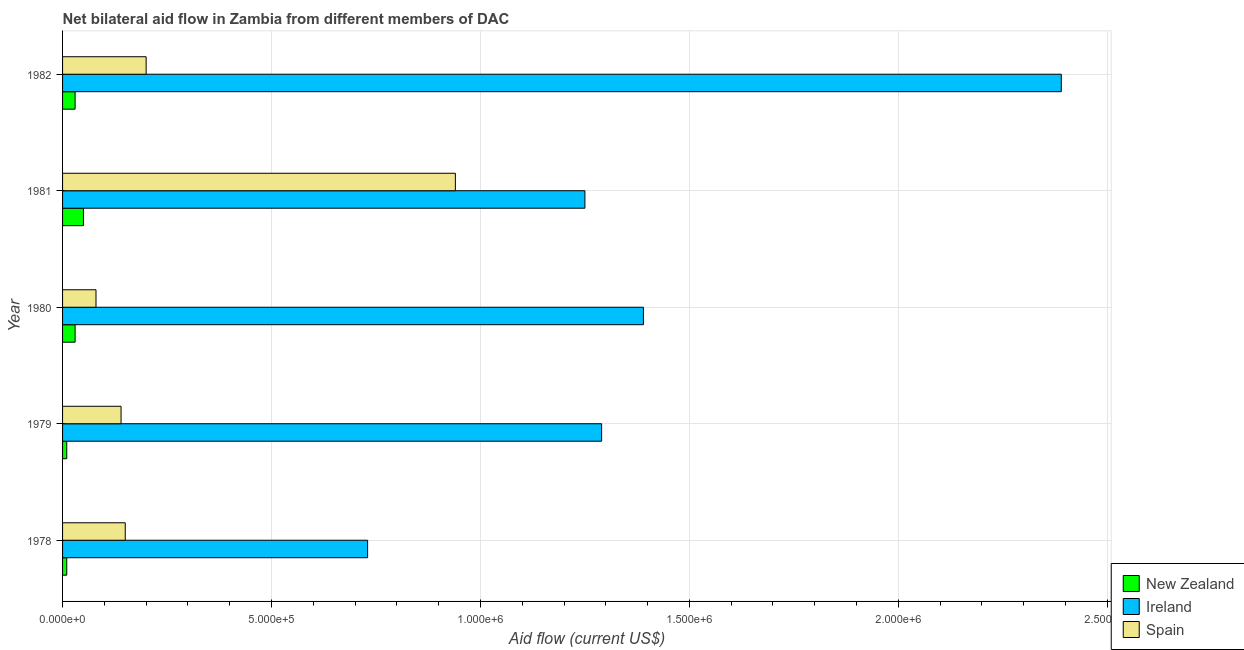How many groups of bars are there?
Your answer should be compact. 5. Are the number of bars per tick equal to the number of legend labels?
Make the answer very short. Yes. How many bars are there on the 3rd tick from the top?
Give a very brief answer. 3. How many bars are there on the 5th tick from the bottom?
Ensure brevity in your answer.  3. What is the label of the 2nd group of bars from the top?
Your answer should be very brief. 1981. What is the amount of aid provided by spain in 1981?
Your answer should be very brief. 9.40e+05. Across all years, what is the maximum amount of aid provided by spain?
Keep it short and to the point. 9.40e+05. Across all years, what is the minimum amount of aid provided by new zealand?
Offer a terse response. 10000. In which year was the amount of aid provided by spain minimum?
Keep it short and to the point. 1980. What is the total amount of aid provided by new zealand in the graph?
Offer a very short reply. 1.30e+05. What is the difference between the amount of aid provided by ireland in 1980 and that in 1982?
Make the answer very short. -1.00e+06. What is the difference between the amount of aid provided by ireland in 1978 and the amount of aid provided by new zealand in 1979?
Offer a very short reply. 7.20e+05. What is the average amount of aid provided by ireland per year?
Your answer should be compact. 1.41e+06. In the year 1980, what is the difference between the amount of aid provided by ireland and amount of aid provided by spain?
Provide a succinct answer. 1.31e+06. In how many years, is the amount of aid provided by new zealand greater than 1600000 US$?
Provide a succinct answer. 0. What is the ratio of the amount of aid provided by new zealand in 1979 to that in 1982?
Make the answer very short. 0.33. What is the difference between the highest and the lowest amount of aid provided by ireland?
Keep it short and to the point. 1.66e+06. In how many years, is the amount of aid provided by ireland greater than the average amount of aid provided by ireland taken over all years?
Keep it short and to the point. 1. What does the 2nd bar from the top in 1980 represents?
Your answer should be compact. Ireland. What does the 3rd bar from the bottom in 1981 represents?
Offer a terse response. Spain. How many bars are there?
Ensure brevity in your answer.  15. Are the values on the major ticks of X-axis written in scientific E-notation?
Your response must be concise. Yes. Where does the legend appear in the graph?
Your response must be concise. Bottom right. How many legend labels are there?
Give a very brief answer. 3. How are the legend labels stacked?
Give a very brief answer. Vertical. What is the title of the graph?
Your response must be concise. Net bilateral aid flow in Zambia from different members of DAC. What is the label or title of the Y-axis?
Ensure brevity in your answer.  Year. What is the Aid flow (current US$) of Ireland in 1978?
Keep it short and to the point. 7.30e+05. What is the Aid flow (current US$) of New Zealand in 1979?
Offer a very short reply. 10000. What is the Aid flow (current US$) in Ireland in 1979?
Your response must be concise. 1.29e+06. What is the Aid flow (current US$) in Spain in 1979?
Your answer should be very brief. 1.40e+05. What is the Aid flow (current US$) in New Zealand in 1980?
Keep it short and to the point. 3.00e+04. What is the Aid flow (current US$) of Ireland in 1980?
Offer a terse response. 1.39e+06. What is the Aid flow (current US$) of Spain in 1980?
Your answer should be compact. 8.00e+04. What is the Aid flow (current US$) in Ireland in 1981?
Your answer should be compact. 1.25e+06. What is the Aid flow (current US$) of Spain in 1981?
Your answer should be compact. 9.40e+05. What is the Aid flow (current US$) of Ireland in 1982?
Ensure brevity in your answer.  2.39e+06. Across all years, what is the maximum Aid flow (current US$) of New Zealand?
Offer a terse response. 5.00e+04. Across all years, what is the maximum Aid flow (current US$) in Ireland?
Your answer should be compact. 2.39e+06. Across all years, what is the maximum Aid flow (current US$) in Spain?
Ensure brevity in your answer.  9.40e+05. Across all years, what is the minimum Aid flow (current US$) in Ireland?
Your answer should be compact. 7.30e+05. Across all years, what is the minimum Aid flow (current US$) in Spain?
Provide a short and direct response. 8.00e+04. What is the total Aid flow (current US$) in New Zealand in the graph?
Your response must be concise. 1.30e+05. What is the total Aid flow (current US$) in Ireland in the graph?
Give a very brief answer. 7.05e+06. What is the total Aid flow (current US$) of Spain in the graph?
Keep it short and to the point. 1.51e+06. What is the difference between the Aid flow (current US$) of New Zealand in 1978 and that in 1979?
Give a very brief answer. 0. What is the difference between the Aid flow (current US$) in Ireland in 1978 and that in 1979?
Your answer should be very brief. -5.60e+05. What is the difference between the Aid flow (current US$) of Spain in 1978 and that in 1979?
Provide a short and direct response. 10000. What is the difference between the Aid flow (current US$) in New Zealand in 1978 and that in 1980?
Provide a succinct answer. -2.00e+04. What is the difference between the Aid flow (current US$) in Ireland in 1978 and that in 1980?
Offer a very short reply. -6.60e+05. What is the difference between the Aid flow (current US$) in Ireland in 1978 and that in 1981?
Offer a very short reply. -5.20e+05. What is the difference between the Aid flow (current US$) in Spain in 1978 and that in 1981?
Offer a very short reply. -7.90e+05. What is the difference between the Aid flow (current US$) in New Zealand in 1978 and that in 1982?
Offer a very short reply. -2.00e+04. What is the difference between the Aid flow (current US$) in Ireland in 1978 and that in 1982?
Your answer should be very brief. -1.66e+06. What is the difference between the Aid flow (current US$) in Spain in 1978 and that in 1982?
Provide a succinct answer. -5.00e+04. What is the difference between the Aid flow (current US$) of New Zealand in 1979 and that in 1980?
Provide a succinct answer. -2.00e+04. What is the difference between the Aid flow (current US$) of Ireland in 1979 and that in 1980?
Offer a terse response. -1.00e+05. What is the difference between the Aid flow (current US$) in Spain in 1979 and that in 1981?
Give a very brief answer. -8.00e+05. What is the difference between the Aid flow (current US$) in Ireland in 1979 and that in 1982?
Make the answer very short. -1.10e+06. What is the difference between the Aid flow (current US$) of Spain in 1979 and that in 1982?
Provide a succinct answer. -6.00e+04. What is the difference between the Aid flow (current US$) of Ireland in 1980 and that in 1981?
Your response must be concise. 1.40e+05. What is the difference between the Aid flow (current US$) in Spain in 1980 and that in 1981?
Your answer should be compact. -8.60e+05. What is the difference between the Aid flow (current US$) in Spain in 1980 and that in 1982?
Your answer should be very brief. -1.20e+05. What is the difference between the Aid flow (current US$) in New Zealand in 1981 and that in 1982?
Provide a short and direct response. 2.00e+04. What is the difference between the Aid flow (current US$) in Ireland in 1981 and that in 1982?
Give a very brief answer. -1.14e+06. What is the difference between the Aid flow (current US$) of Spain in 1981 and that in 1982?
Your response must be concise. 7.40e+05. What is the difference between the Aid flow (current US$) in New Zealand in 1978 and the Aid flow (current US$) in Ireland in 1979?
Your answer should be very brief. -1.28e+06. What is the difference between the Aid flow (current US$) of New Zealand in 1978 and the Aid flow (current US$) of Spain in 1979?
Your response must be concise. -1.30e+05. What is the difference between the Aid flow (current US$) of Ireland in 1978 and the Aid flow (current US$) of Spain in 1979?
Make the answer very short. 5.90e+05. What is the difference between the Aid flow (current US$) in New Zealand in 1978 and the Aid flow (current US$) in Ireland in 1980?
Your answer should be compact. -1.38e+06. What is the difference between the Aid flow (current US$) of New Zealand in 1978 and the Aid flow (current US$) of Spain in 1980?
Make the answer very short. -7.00e+04. What is the difference between the Aid flow (current US$) of Ireland in 1978 and the Aid flow (current US$) of Spain in 1980?
Offer a very short reply. 6.50e+05. What is the difference between the Aid flow (current US$) in New Zealand in 1978 and the Aid flow (current US$) in Ireland in 1981?
Offer a terse response. -1.24e+06. What is the difference between the Aid flow (current US$) of New Zealand in 1978 and the Aid flow (current US$) of Spain in 1981?
Your answer should be very brief. -9.30e+05. What is the difference between the Aid flow (current US$) in New Zealand in 1978 and the Aid flow (current US$) in Ireland in 1982?
Your response must be concise. -2.38e+06. What is the difference between the Aid flow (current US$) in Ireland in 1978 and the Aid flow (current US$) in Spain in 1982?
Keep it short and to the point. 5.30e+05. What is the difference between the Aid flow (current US$) in New Zealand in 1979 and the Aid flow (current US$) in Ireland in 1980?
Offer a terse response. -1.38e+06. What is the difference between the Aid flow (current US$) of New Zealand in 1979 and the Aid flow (current US$) of Spain in 1980?
Your response must be concise. -7.00e+04. What is the difference between the Aid flow (current US$) in Ireland in 1979 and the Aid flow (current US$) in Spain in 1980?
Your answer should be very brief. 1.21e+06. What is the difference between the Aid flow (current US$) in New Zealand in 1979 and the Aid flow (current US$) in Ireland in 1981?
Your answer should be compact. -1.24e+06. What is the difference between the Aid flow (current US$) in New Zealand in 1979 and the Aid flow (current US$) in Spain in 1981?
Provide a short and direct response. -9.30e+05. What is the difference between the Aid flow (current US$) of Ireland in 1979 and the Aid flow (current US$) of Spain in 1981?
Your response must be concise. 3.50e+05. What is the difference between the Aid flow (current US$) in New Zealand in 1979 and the Aid flow (current US$) in Ireland in 1982?
Ensure brevity in your answer.  -2.38e+06. What is the difference between the Aid flow (current US$) in Ireland in 1979 and the Aid flow (current US$) in Spain in 1982?
Ensure brevity in your answer.  1.09e+06. What is the difference between the Aid flow (current US$) of New Zealand in 1980 and the Aid flow (current US$) of Ireland in 1981?
Offer a terse response. -1.22e+06. What is the difference between the Aid flow (current US$) of New Zealand in 1980 and the Aid flow (current US$) of Spain in 1981?
Your answer should be very brief. -9.10e+05. What is the difference between the Aid flow (current US$) in Ireland in 1980 and the Aid flow (current US$) in Spain in 1981?
Offer a terse response. 4.50e+05. What is the difference between the Aid flow (current US$) of New Zealand in 1980 and the Aid flow (current US$) of Ireland in 1982?
Offer a terse response. -2.36e+06. What is the difference between the Aid flow (current US$) of New Zealand in 1980 and the Aid flow (current US$) of Spain in 1982?
Ensure brevity in your answer.  -1.70e+05. What is the difference between the Aid flow (current US$) in Ireland in 1980 and the Aid flow (current US$) in Spain in 1982?
Keep it short and to the point. 1.19e+06. What is the difference between the Aid flow (current US$) in New Zealand in 1981 and the Aid flow (current US$) in Ireland in 1982?
Provide a short and direct response. -2.34e+06. What is the difference between the Aid flow (current US$) of New Zealand in 1981 and the Aid flow (current US$) of Spain in 1982?
Offer a terse response. -1.50e+05. What is the difference between the Aid flow (current US$) of Ireland in 1981 and the Aid flow (current US$) of Spain in 1982?
Offer a very short reply. 1.05e+06. What is the average Aid flow (current US$) in New Zealand per year?
Your answer should be very brief. 2.60e+04. What is the average Aid flow (current US$) of Ireland per year?
Keep it short and to the point. 1.41e+06. What is the average Aid flow (current US$) in Spain per year?
Your answer should be very brief. 3.02e+05. In the year 1978, what is the difference between the Aid flow (current US$) in New Zealand and Aid flow (current US$) in Ireland?
Offer a terse response. -7.20e+05. In the year 1978, what is the difference between the Aid flow (current US$) of New Zealand and Aid flow (current US$) of Spain?
Offer a terse response. -1.40e+05. In the year 1978, what is the difference between the Aid flow (current US$) of Ireland and Aid flow (current US$) of Spain?
Your response must be concise. 5.80e+05. In the year 1979, what is the difference between the Aid flow (current US$) of New Zealand and Aid flow (current US$) of Ireland?
Make the answer very short. -1.28e+06. In the year 1979, what is the difference between the Aid flow (current US$) in Ireland and Aid flow (current US$) in Spain?
Your answer should be compact. 1.15e+06. In the year 1980, what is the difference between the Aid flow (current US$) of New Zealand and Aid flow (current US$) of Ireland?
Your answer should be very brief. -1.36e+06. In the year 1980, what is the difference between the Aid flow (current US$) of New Zealand and Aid flow (current US$) of Spain?
Make the answer very short. -5.00e+04. In the year 1980, what is the difference between the Aid flow (current US$) in Ireland and Aid flow (current US$) in Spain?
Your response must be concise. 1.31e+06. In the year 1981, what is the difference between the Aid flow (current US$) of New Zealand and Aid flow (current US$) of Ireland?
Your response must be concise. -1.20e+06. In the year 1981, what is the difference between the Aid flow (current US$) of New Zealand and Aid flow (current US$) of Spain?
Give a very brief answer. -8.90e+05. In the year 1981, what is the difference between the Aid flow (current US$) of Ireland and Aid flow (current US$) of Spain?
Keep it short and to the point. 3.10e+05. In the year 1982, what is the difference between the Aid flow (current US$) of New Zealand and Aid flow (current US$) of Ireland?
Provide a short and direct response. -2.36e+06. In the year 1982, what is the difference between the Aid flow (current US$) in New Zealand and Aid flow (current US$) in Spain?
Your response must be concise. -1.70e+05. In the year 1982, what is the difference between the Aid flow (current US$) of Ireland and Aid flow (current US$) of Spain?
Your response must be concise. 2.19e+06. What is the ratio of the Aid flow (current US$) of New Zealand in 1978 to that in 1979?
Make the answer very short. 1. What is the ratio of the Aid flow (current US$) of Ireland in 1978 to that in 1979?
Make the answer very short. 0.57. What is the ratio of the Aid flow (current US$) in Spain in 1978 to that in 1979?
Provide a succinct answer. 1.07. What is the ratio of the Aid flow (current US$) in New Zealand in 1978 to that in 1980?
Provide a succinct answer. 0.33. What is the ratio of the Aid flow (current US$) in Ireland in 1978 to that in 1980?
Offer a terse response. 0.53. What is the ratio of the Aid flow (current US$) in Spain in 1978 to that in 1980?
Give a very brief answer. 1.88. What is the ratio of the Aid flow (current US$) of New Zealand in 1978 to that in 1981?
Offer a very short reply. 0.2. What is the ratio of the Aid flow (current US$) of Ireland in 1978 to that in 1981?
Your answer should be compact. 0.58. What is the ratio of the Aid flow (current US$) of Spain in 1978 to that in 1981?
Ensure brevity in your answer.  0.16. What is the ratio of the Aid flow (current US$) in Ireland in 1978 to that in 1982?
Ensure brevity in your answer.  0.31. What is the ratio of the Aid flow (current US$) of Spain in 1978 to that in 1982?
Give a very brief answer. 0.75. What is the ratio of the Aid flow (current US$) of New Zealand in 1979 to that in 1980?
Offer a very short reply. 0.33. What is the ratio of the Aid flow (current US$) of Ireland in 1979 to that in 1980?
Keep it short and to the point. 0.93. What is the ratio of the Aid flow (current US$) in Spain in 1979 to that in 1980?
Offer a terse response. 1.75. What is the ratio of the Aid flow (current US$) of Ireland in 1979 to that in 1981?
Offer a terse response. 1.03. What is the ratio of the Aid flow (current US$) of Spain in 1979 to that in 1981?
Offer a terse response. 0.15. What is the ratio of the Aid flow (current US$) of Ireland in 1979 to that in 1982?
Ensure brevity in your answer.  0.54. What is the ratio of the Aid flow (current US$) of Spain in 1979 to that in 1982?
Provide a short and direct response. 0.7. What is the ratio of the Aid flow (current US$) of New Zealand in 1980 to that in 1981?
Your answer should be compact. 0.6. What is the ratio of the Aid flow (current US$) of Ireland in 1980 to that in 1981?
Ensure brevity in your answer.  1.11. What is the ratio of the Aid flow (current US$) in Spain in 1980 to that in 1981?
Give a very brief answer. 0.09. What is the ratio of the Aid flow (current US$) in Ireland in 1980 to that in 1982?
Your response must be concise. 0.58. What is the ratio of the Aid flow (current US$) of New Zealand in 1981 to that in 1982?
Keep it short and to the point. 1.67. What is the ratio of the Aid flow (current US$) in Ireland in 1981 to that in 1982?
Your answer should be compact. 0.52. What is the ratio of the Aid flow (current US$) of Spain in 1981 to that in 1982?
Provide a short and direct response. 4.7. What is the difference between the highest and the second highest Aid flow (current US$) in Ireland?
Make the answer very short. 1.00e+06. What is the difference between the highest and the second highest Aid flow (current US$) in Spain?
Provide a succinct answer. 7.40e+05. What is the difference between the highest and the lowest Aid flow (current US$) of New Zealand?
Ensure brevity in your answer.  4.00e+04. What is the difference between the highest and the lowest Aid flow (current US$) in Ireland?
Make the answer very short. 1.66e+06. What is the difference between the highest and the lowest Aid flow (current US$) in Spain?
Your response must be concise. 8.60e+05. 